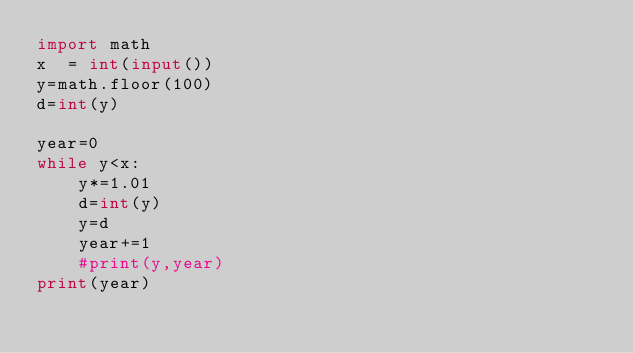Convert code to text. <code><loc_0><loc_0><loc_500><loc_500><_Python_>import math
x  = int(input())
y=math.floor(100)
d=int(y)
 
year=0
while y<x:
    y*=1.01
    d=int(y)
    y=d
    year+=1
    #print(y,year)
print(year)</code> 